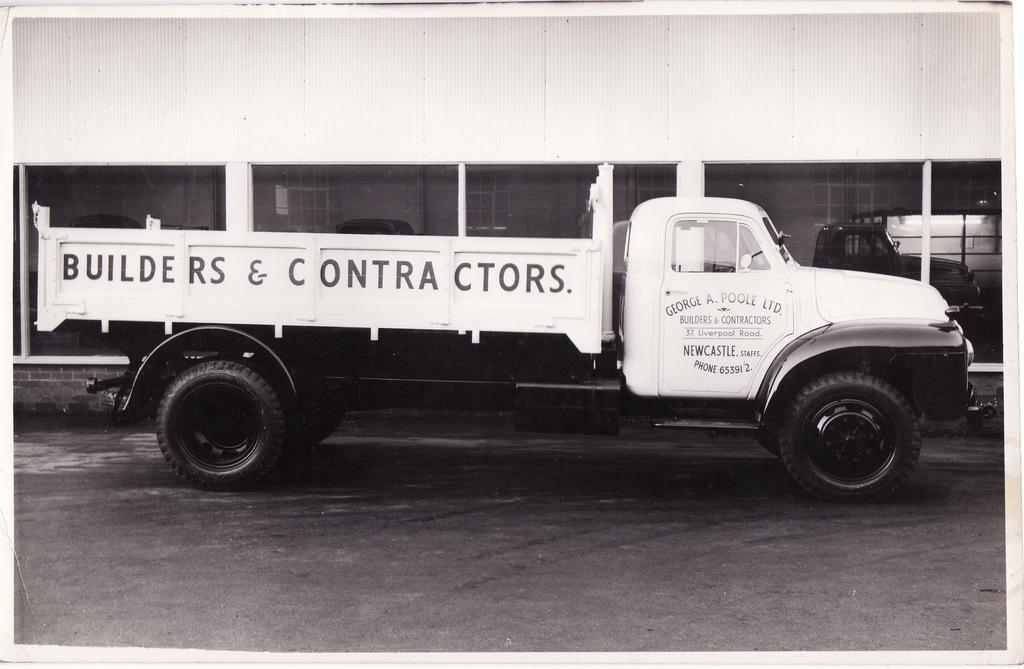What type of vehicle is in the image? There is a truck in the image. Where is the truck located? The truck is on the road. What type of building is in the image? There is a building with a glass wall in the image. What can be seen in the reflection on the glass wall? The glass wall has a reflection of the vehicle, which is the truck. What type of pear is being used as a guide for the truck in the image? There is no pear present in the image, and the truck is not being guided by any fruit. 